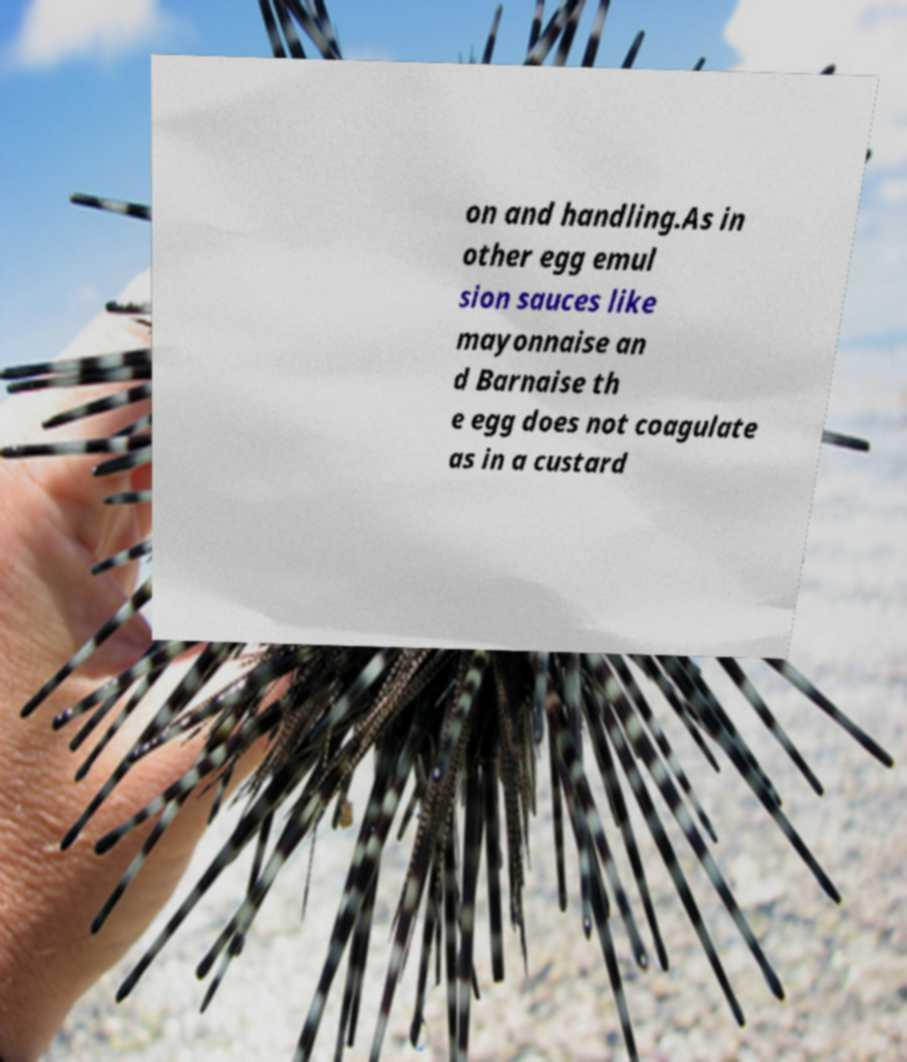Could you extract and type out the text from this image? on and handling.As in other egg emul sion sauces like mayonnaise an d Barnaise th e egg does not coagulate as in a custard 